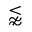<formula> <loc_0><loc_0><loc_500><loc_500>\lnapprox</formula> 